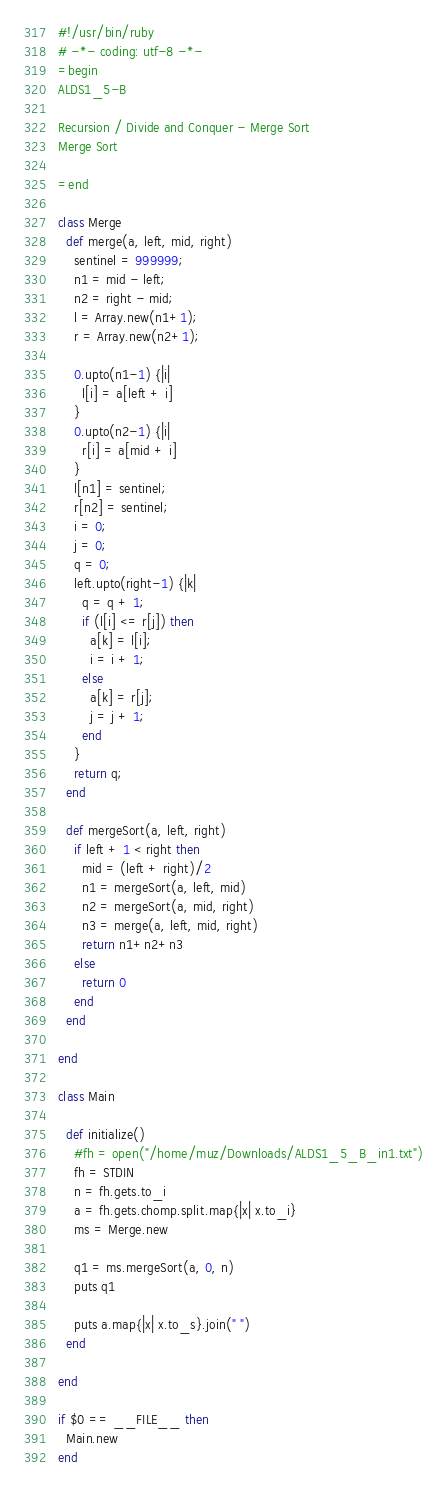<code> <loc_0><loc_0><loc_500><loc_500><_Ruby_>#!/usr/bin/ruby
# -*- coding: utf-8 -*-
=begin
ALDS1_5-B

Recursion / Divide and Conquer - Merge Sort
Merge Sort

=end

class Merge
  def merge(a, left, mid, right)
    sentinel = 999999;
    n1 = mid - left;
    n2 = right - mid;
    l = Array.new(n1+1);
    r = Array.new(n2+1);

    0.upto(n1-1) {|i|
      l[i] = a[left + i]
    }
    0.upto(n2-1) {|i|
      r[i] = a[mid + i]
    }
    l[n1] = sentinel;
    r[n2] = sentinel;
    i = 0;
    j = 0;
    q = 0;
    left.upto(right-1) {|k|
      q = q + 1;
      if (l[i] <= r[j]) then
        a[k] = l[i];
        i = i + 1;
      else
        a[k] = r[j];
        j = j + 1;
      end
    }
    return q;
  end

  def mergeSort(a, left, right)
    if left + 1 < right then
      mid = (left + right)/2
      n1 = mergeSort(a, left, mid)
      n2 = mergeSort(a, mid, right)
      n3 = merge(a, left, mid, right)
      return n1+n2+n3
    else
      return 0
    end
  end

end

class Main

  def initialize()
    #fh = open("/home/muz/Downloads/ALDS1_5_B_in1.txt")
    fh = STDIN
    n = fh.gets.to_i
    a = fh.gets.chomp.split.map{|x| x.to_i}
    ms = Merge.new

    q1 = ms.mergeSort(a, 0, n)
    puts q1

    puts a.map{|x| x.to_s}.join(" ")
  end

end

if $0 == __FILE__ then
  Main.new
end</code> 